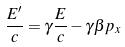Convert formula to latex. <formula><loc_0><loc_0><loc_500><loc_500>\frac { E ^ { \prime } } { c } = \gamma \frac { E } { c } - \gamma \beta p _ { x }</formula> 